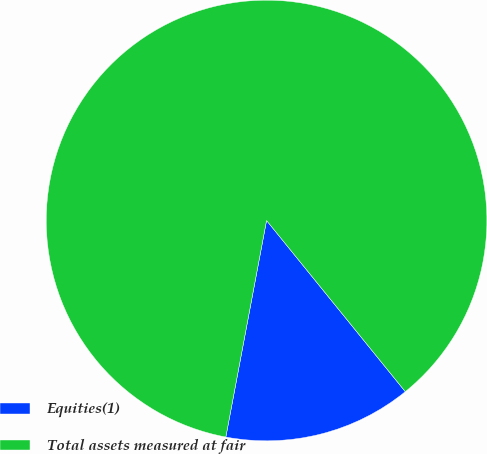<chart> <loc_0><loc_0><loc_500><loc_500><pie_chart><fcel>Equities(1)<fcel>Total assets measured at fair<nl><fcel>13.8%<fcel>86.2%<nl></chart> 